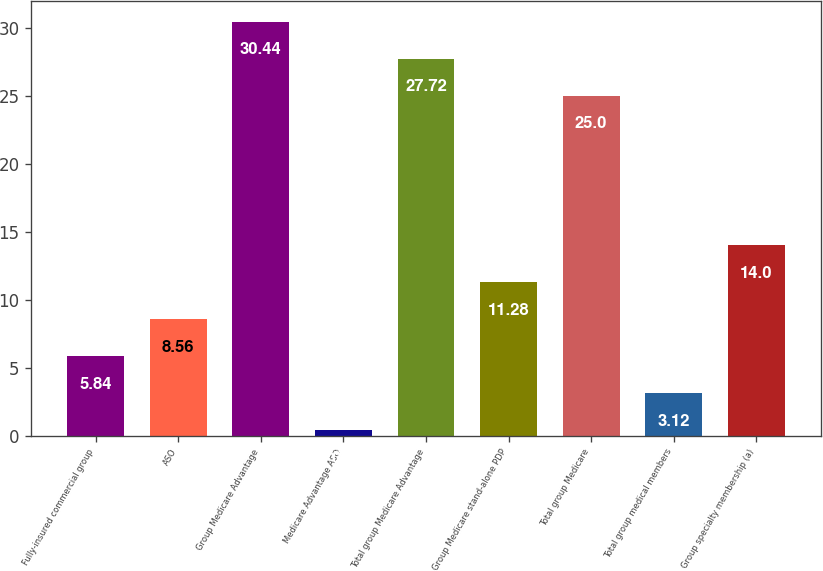Convert chart. <chart><loc_0><loc_0><loc_500><loc_500><bar_chart><fcel>Fully-insured commercial group<fcel>ASO<fcel>Group Medicare Advantage<fcel>Medicare Advantage ASO<fcel>Total group Medicare Advantage<fcel>Group Medicare stand-alone PDP<fcel>Total group Medicare<fcel>Total group medical members<fcel>Group specialty membership (a)<nl><fcel>5.84<fcel>8.56<fcel>30.44<fcel>0.4<fcel>27.72<fcel>11.28<fcel>25<fcel>3.12<fcel>14<nl></chart> 